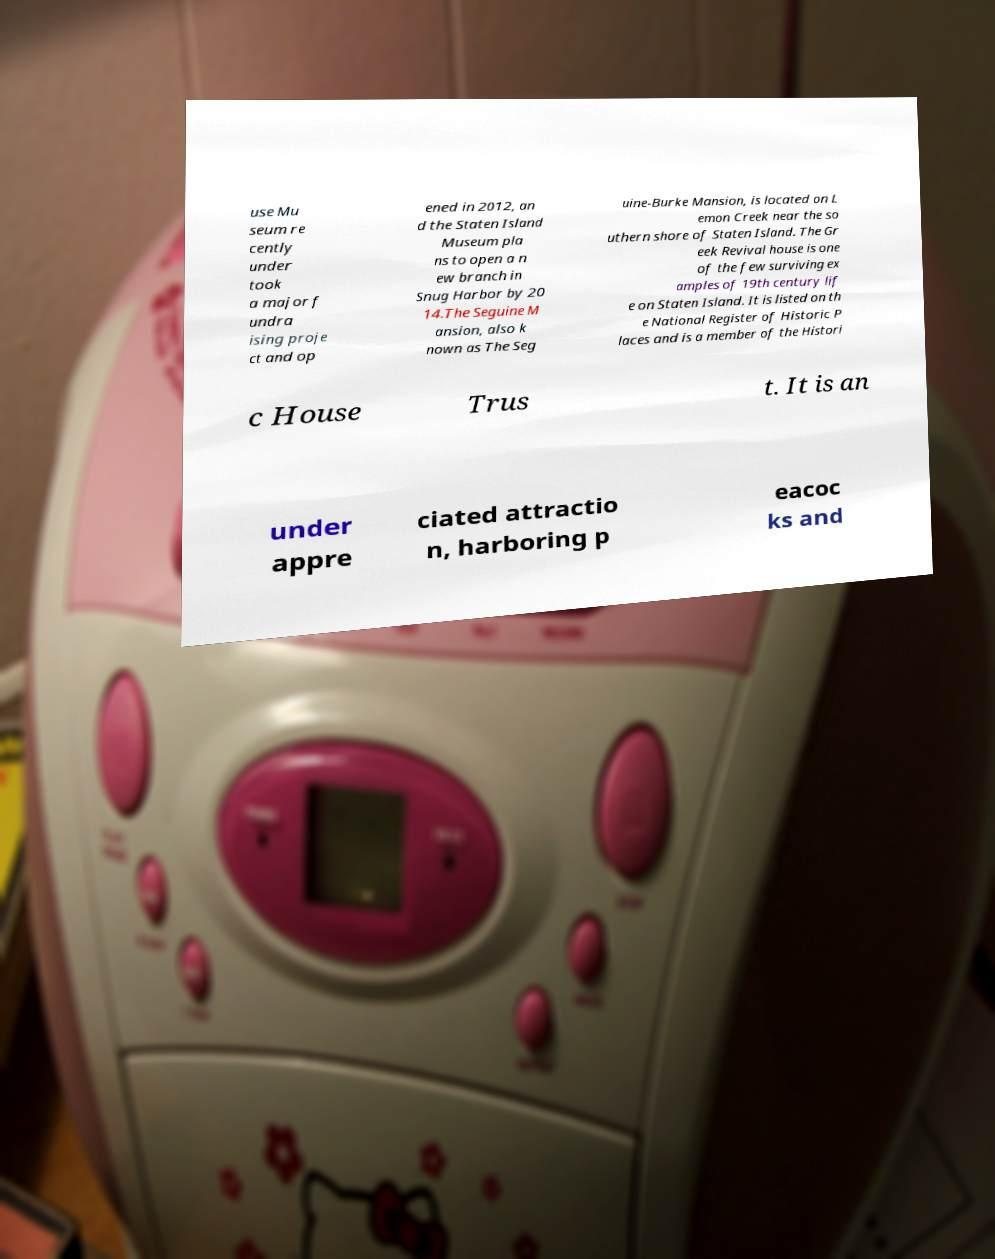Please identify and transcribe the text found in this image. use Mu seum re cently under took a major f undra ising proje ct and op ened in 2012, an d the Staten Island Museum pla ns to open a n ew branch in Snug Harbor by 20 14.The Seguine M ansion, also k nown as The Seg uine-Burke Mansion, is located on L emon Creek near the so uthern shore of Staten Island. The Gr eek Revival house is one of the few surviving ex amples of 19th century lif e on Staten Island. It is listed on th e National Register of Historic P laces and is a member of the Histori c House Trus t. It is an under appre ciated attractio n, harboring p eacoc ks and 